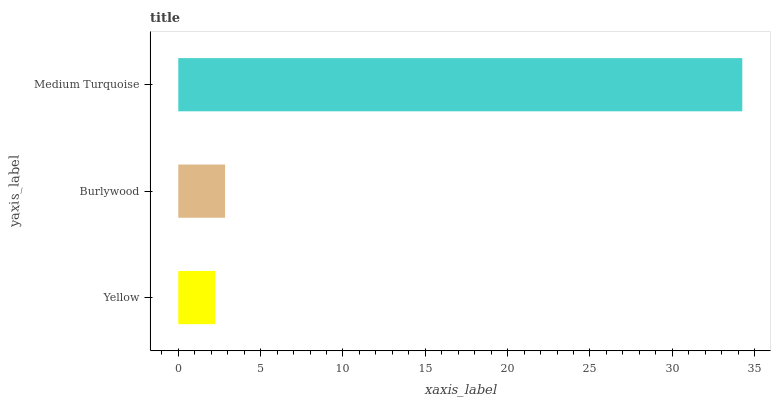Is Yellow the minimum?
Answer yes or no. Yes. Is Medium Turquoise the maximum?
Answer yes or no. Yes. Is Burlywood the minimum?
Answer yes or no. No. Is Burlywood the maximum?
Answer yes or no. No. Is Burlywood greater than Yellow?
Answer yes or no. Yes. Is Yellow less than Burlywood?
Answer yes or no. Yes. Is Yellow greater than Burlywood?
Answer yes or no. No. Is Burlywood less than Yellow?
Answer yes or no. No. Is Burlywood the high median?
Answer yes or no. Yes. Is Burlywood the low median?
Answer yes or no. Yes. Is Yellow the high median?
Answer yes or no. No. Is Medium Turquoise the low median?
Answer yes or no. No. 